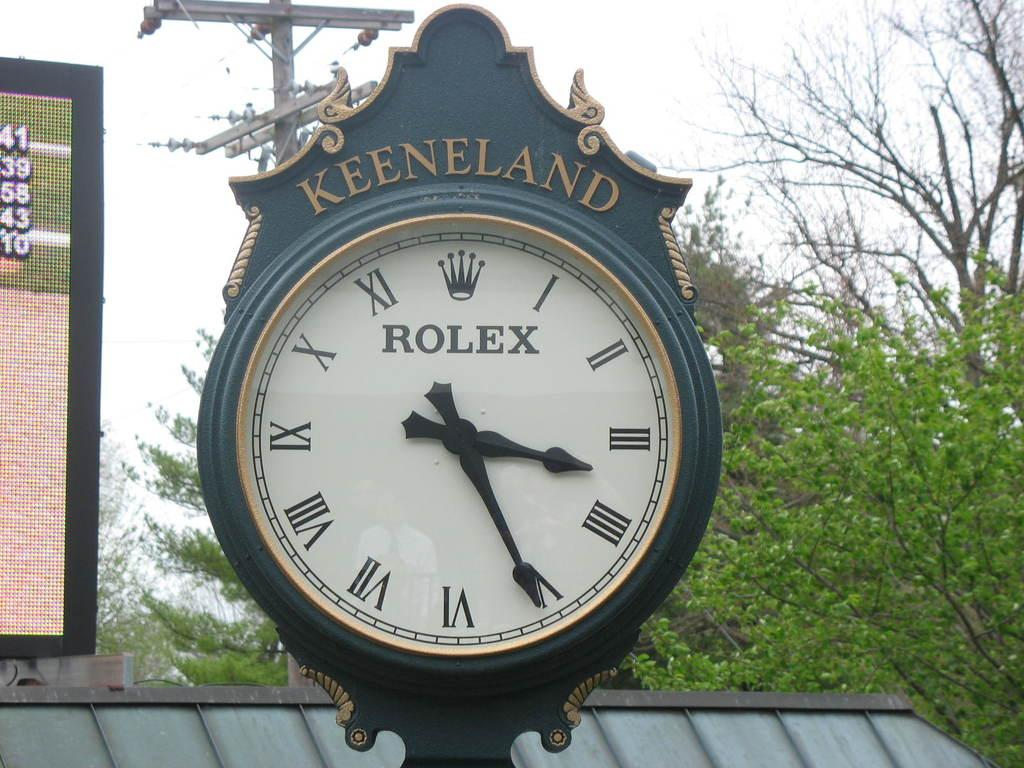<image>
Present a compact description of the photo's key features. Green and white clock which has the word Keeneland on top. 